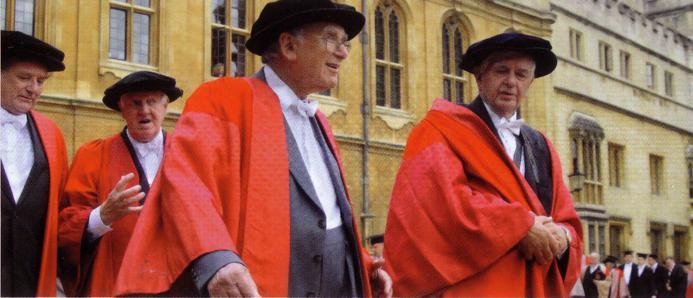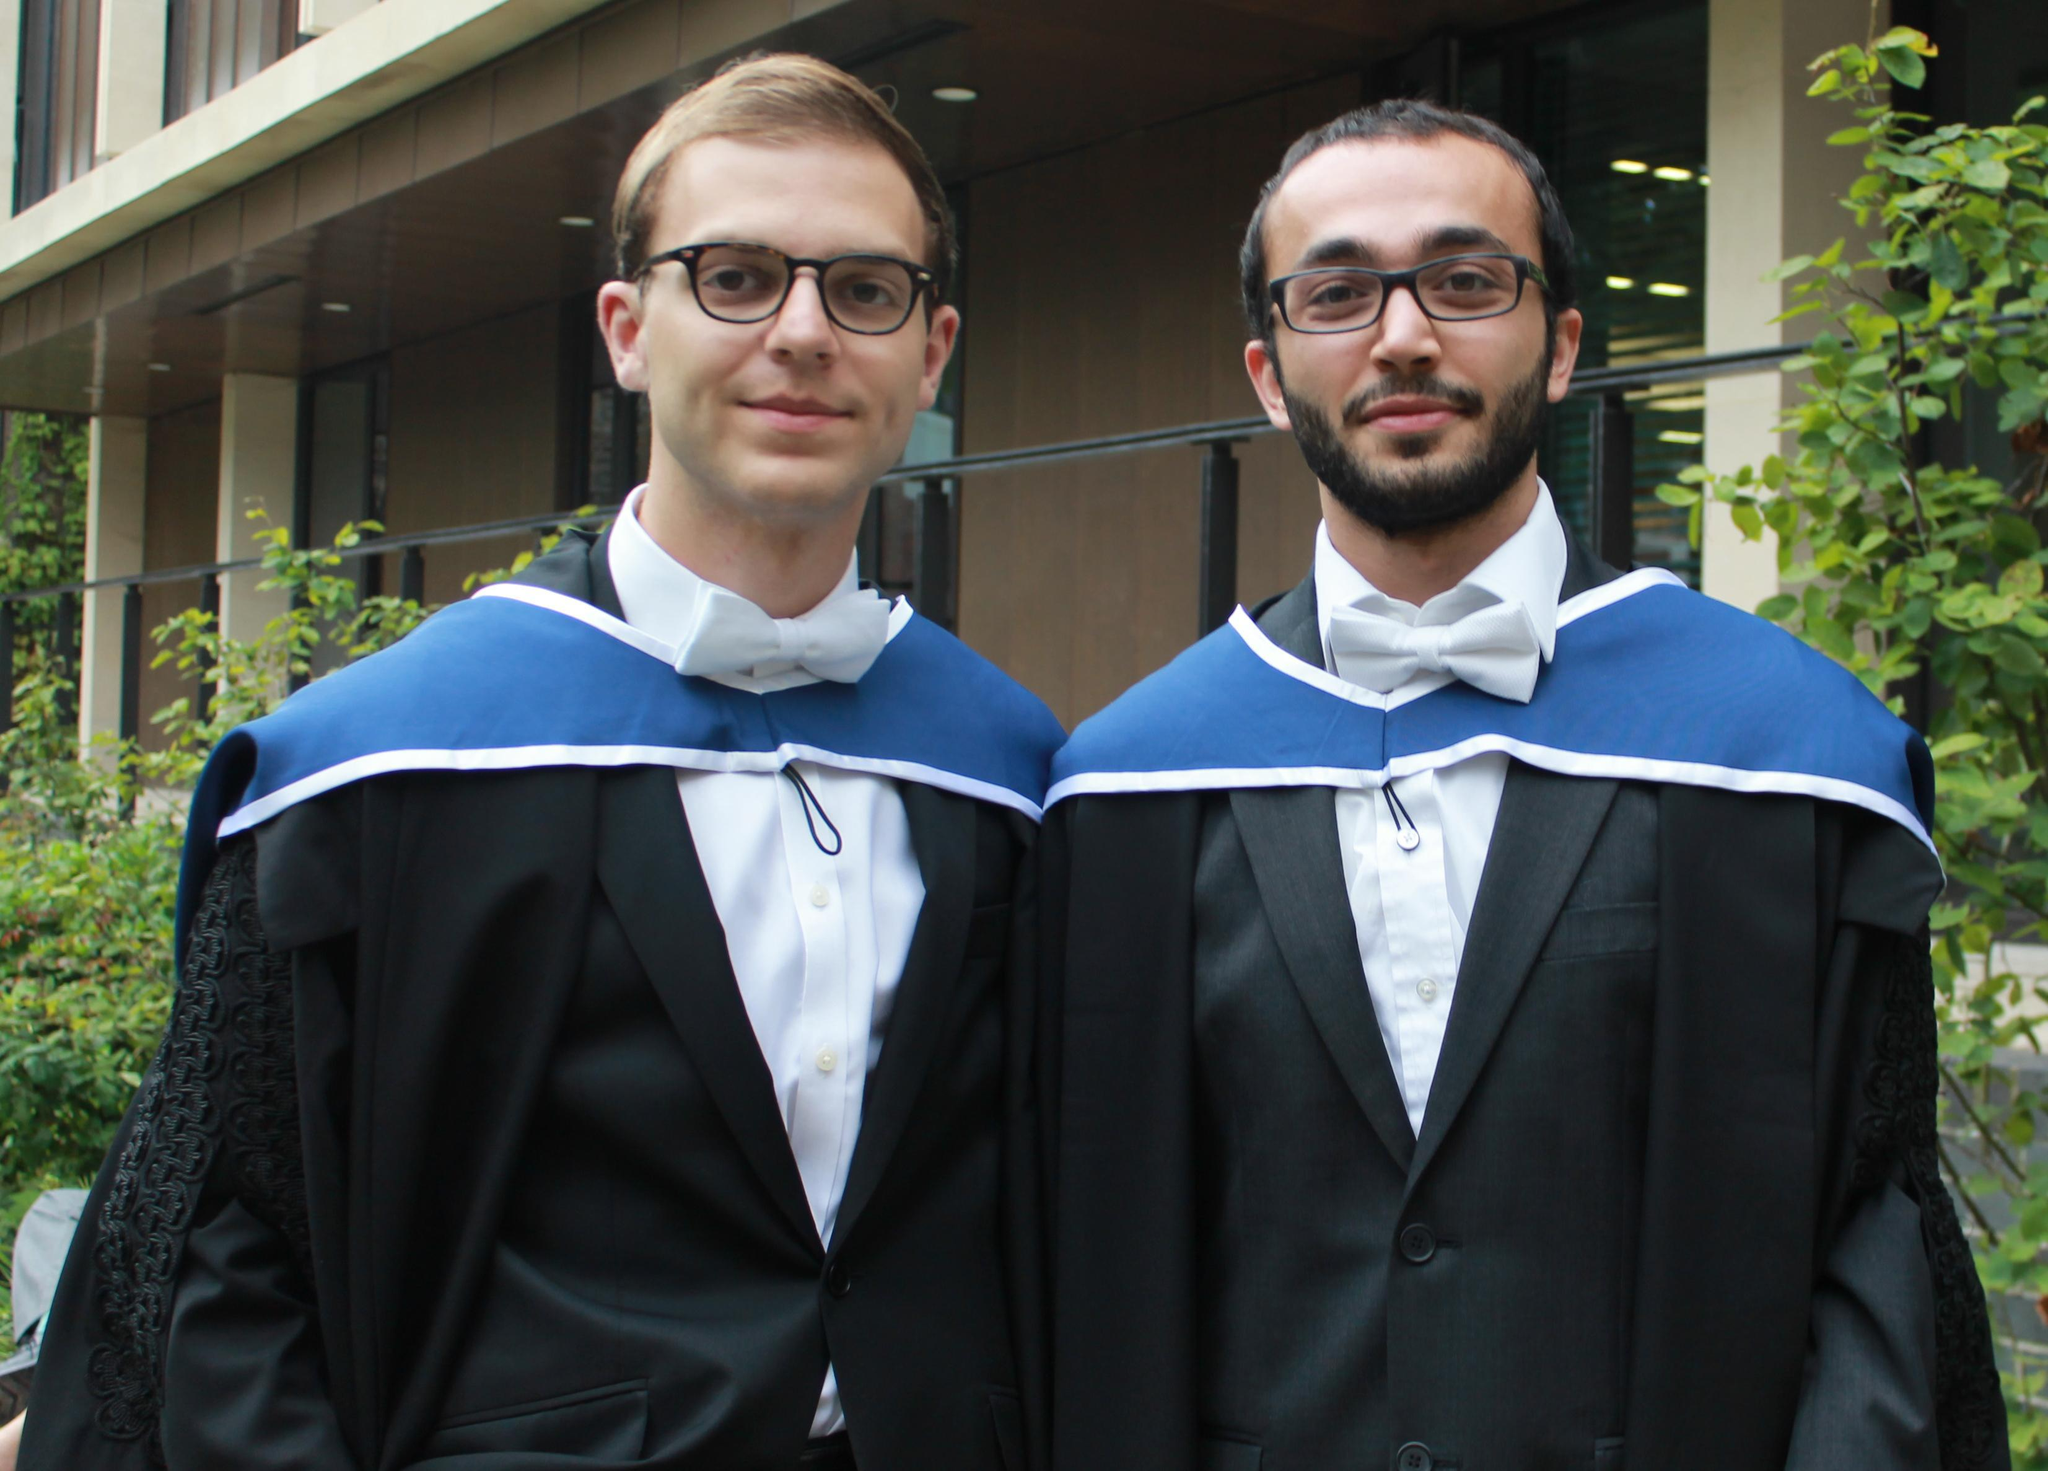The first image is the image on the left, the second image is the image on the right. Analyze the images presented: Is the assertion "There is a lone woman centered in one image." valid? Answer yes or no. No. The first image is the image on the left, the second image is the image on the right. Assess this claim about the two images: "There are at most 3 graduation gowns in the image pair". Correct or not? Answer yes or no. No. 